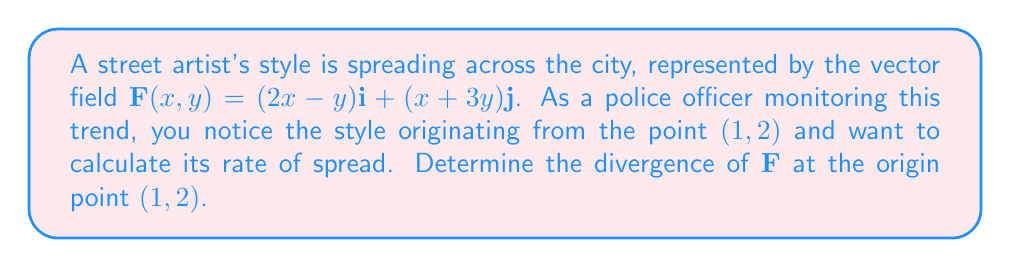Provide a solution to this math problem. To solve this problem, we need to follow these steps:

1) The divergence of a vector field $\mathbf{F}(x,y) = P(x,y)\mathbf{i} + Q(x,y)\mathbf{j}$ is given by:

   $$\text{div}\mathbf{F} = \nabla \cdot \mathbf{F} = \frac{\partial P}{\partial x} + \frac{\partial Q}{\partial y}$$

2) In our case, $P(x,y) = 2x-y$ and $Q(x,y) = x+3y$

3) Let's calculate the partial derivatives:
   
   $$\frac{\partial P}{\partial x} = \frac{\partial}{\partial x}(2x-y) = 2$$
   
   $$\frac{\partial Q}{\partial y} = \frac{\partial}{\partial y}(x+3y) = 3$$

4) Now, we can calculate the divergence:

   $$\text{div}\mathbf{F} = \frac{\partial P}{\partial x} + \frac{\partial Q}{\partial y} = 2 + 3 = 5$$

5) The question asks for the divergence at the point $(1,2)$. However, we can see that the divergence is constant (5) regardless of the point, as it doesn't depend on $x$ or $y$.

Therefore, the divergence of $\mathbf{F}$ at the point $(1,2)$ is 5.
Answer: 5 